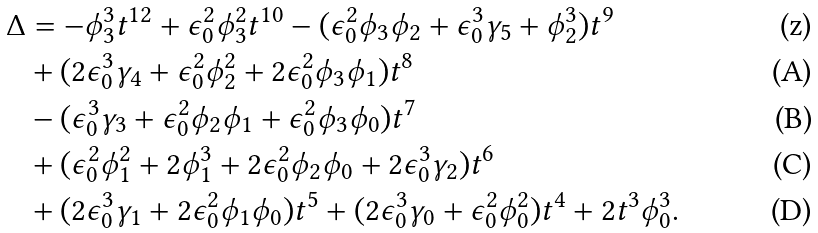Convert formula to latex. <formula><loc_0><loc_0><loc_500><loc_500>\Delta & = - \phi _ { 3 } ^ { 3 } t ^ { 1 2 } + { \epsilon } _ { 0 } ^ { 2 } \phi _ { 3 } ^ { 2 } t ^ { 1 0 } - ( { \epsilon } _ { 0 } ^ { 2 } \phi _ { 3 } \phi _ { 2 } + { \epsilon } _ { 0 } ^ { 3 } \gamma _ { 5 } + \phi _ { 2 } ^ { 3 } ) t ^ { 9 } \\ & + ( 2 { \epsilon } _ { 0 } ^ { 3 } \gamma _ { 4 } + { \epsilon } _ { 0 } ^ { 2 } \phi _ { 2 } ^ { 2 } + 2 { \epsilon } _ { 0 } ^ { 2 } \phi _ { 3 } \phi _ { 1 } ) t ^ { 8 } \\ & - ( { \epsilon } _ { 0 } ^ { 3 } \gamma _ { 3 } + { \epsilon } _ { 0 } ^ { 2 } \phi _ { 2 } \phi _ { 1 } + { \epsilon } _ { 0 } ^ { 2 } \phi _ { 3 } \phi _ { 0 } ) t ^ { 7 } \\ & + ( { \epsilon } _ { 0 } ^ { 2 } \phi _ { 1 } ^ { 2 } + 2 \phi _ { 1 } ^ { 3 } + 2 { \epsilon } _ { 0 } ^ { 2 } \phi _ { 2 } \phi _ { 0 } + 2 { \epsilon } _ { 0 } ^ { 3 } \gamma _ { 2 } ) t ^ { 6 } \\ & + ( 2 { \epsilon } _ { 0 } ^ { 3 } \gamma _ { 1 } + 2 { \epsilon } _ { 0 } ^ { 2 } \phi _ { 1 } \phi _ { 0 } ) t ^ { 5 } + ( 2 { \epsilon } _ { 0 } ^ { 3 } \gamma _ { 0 } + { \epsilon } _ { 0 } ^ { 2 } \phi _ { 0 } ^ { 2 } ) t ^ { 4 } + 2 t ^ { 3 } \phi _ { 0 } ^ { 3 } .</formula> 